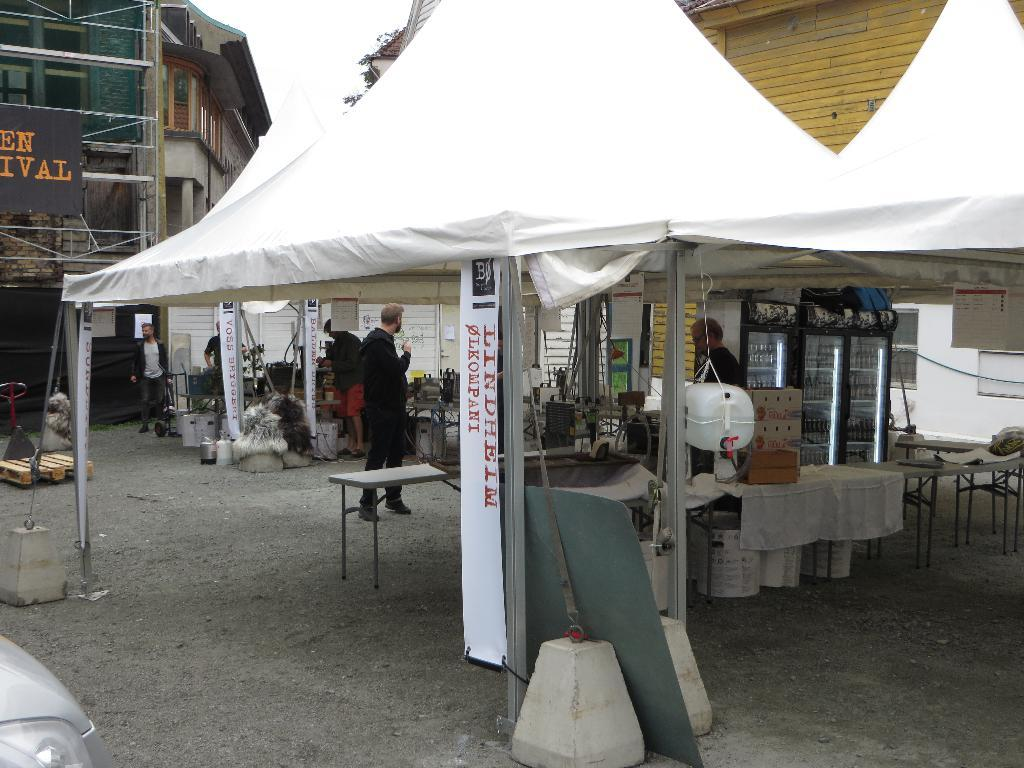What structure is visible in the image? There is a tent in the image. What are the people inside the tent doing? The people are on the floor inside the tent. What can be seen in the background of the image? There are buildings and the sky visible in the background of the image. How much tax is being paid by the people inside the tent in the image? There is no information about tax in the image, as it features a tent with people inside and a background with buildings and the sky. 